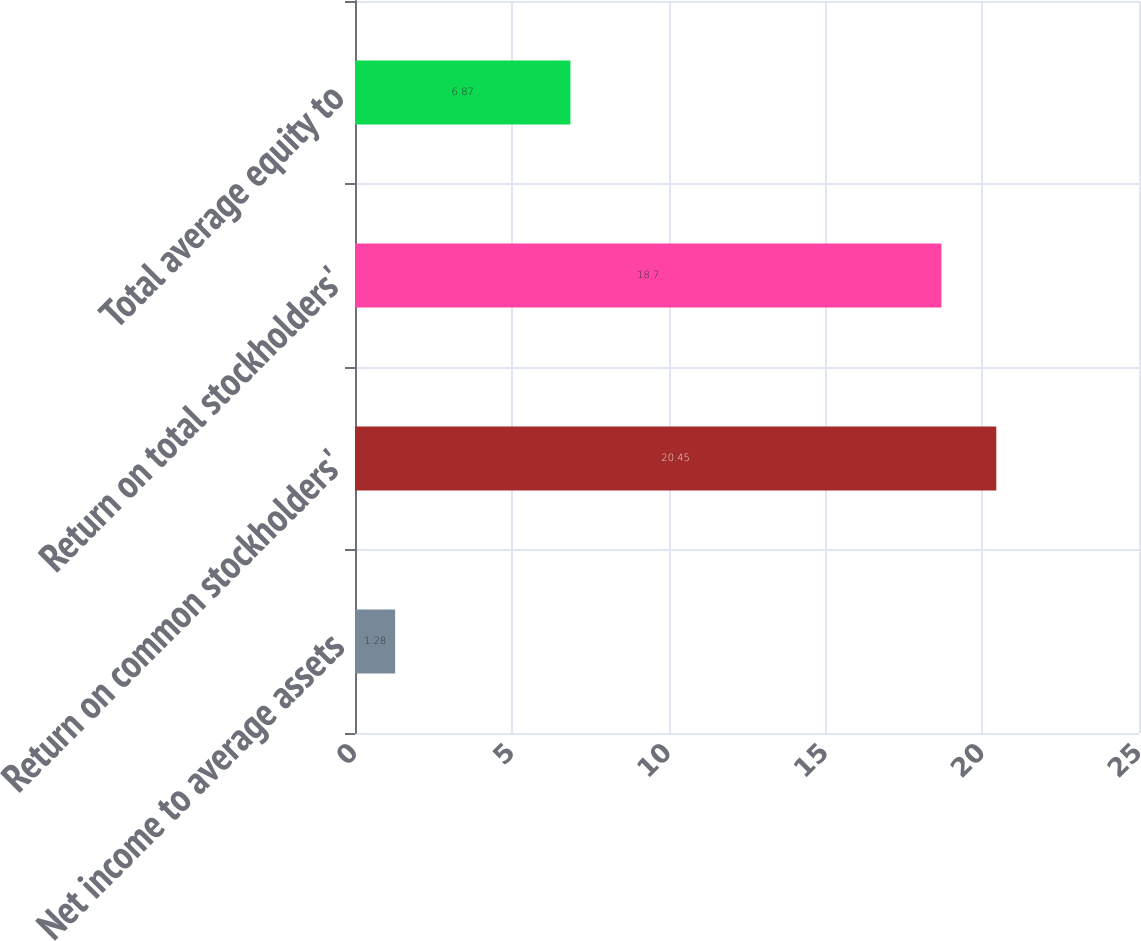Convert chart to OTSL. <chart><loc_0><loc_0><loc_500><loc_500><bar_chart><fcel>Net income to average assets<fcel>Return on common stockholders'<fcel>Return on total stockholders'<fcel>Total average equity to<nl><fcel>1.28<fcel>20.45<fcel>18.7<fcel>6.87<nl></chart> 